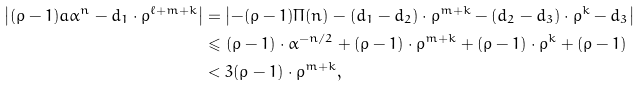<formula> <loc_0><loc_0><loc_500><loc_500>\left | ( \rho - 1 ) a \alpha ^ { n } - d _ { 1 } \cdot \rho ^ { \ell + m + k } \right | & = \left | - ( \rho - 1 ) \Pi ( n ) - ( d _ { 1 } - d _ { 2 } ) \cdot \rho ^ { m + k } - ( d _ { 2 } - d _ { 3 } ) \cdot \rho ^ { k } - d _ { 3 } \right | \\ & \leqslant ( \rho - 1 ) \cdot \alpha ^ { - n / 2 } + ( \rho - 1 ) \cdot \rho ^ { m + k } + ( \rho - 1 ) \cdot \rho ^ { k } + ( \rho - 1 ) \\ & < 3 ( \rho - 1 ) \cdot \rho ^ { m + k } ,</formula> 